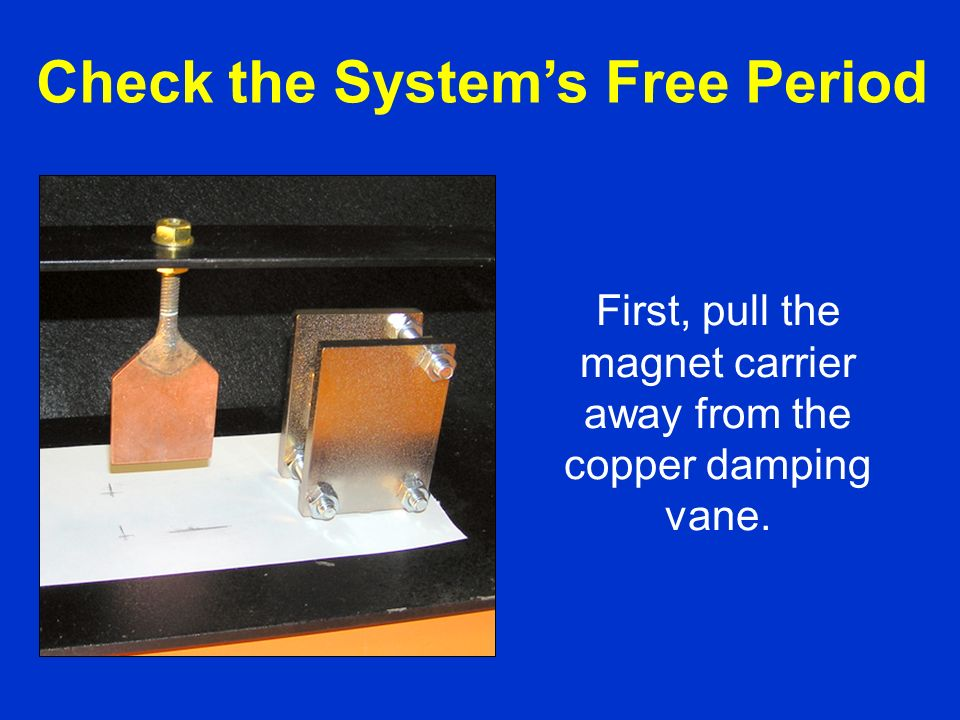Considering the setup shown, what could be the scientific principle or phenomenon that this experiment is designed to demonstrate or measure, based on the components and their arrangement? The setup with the magnet situated adjacent to the copper damping vane demonstrates the scientific principle of magnetic damping. In this experiment, pulling the magnet carrier away from the copper damping vane allows the observation of how a moving magnet induces eddy currents in the nearby copper plates. These eddy currents create a magnetic field that opposes the motion of the magnet, thereby slowing it down, a phenomenon known as magnetic damping. This is a practical demonstration of Lenz's Law, which is a fundamental concept in electromagnetism. It states that the direction of induced current will oppose the change in magnetic flux that produced it, showcasing energy conversion and conservation principles. 